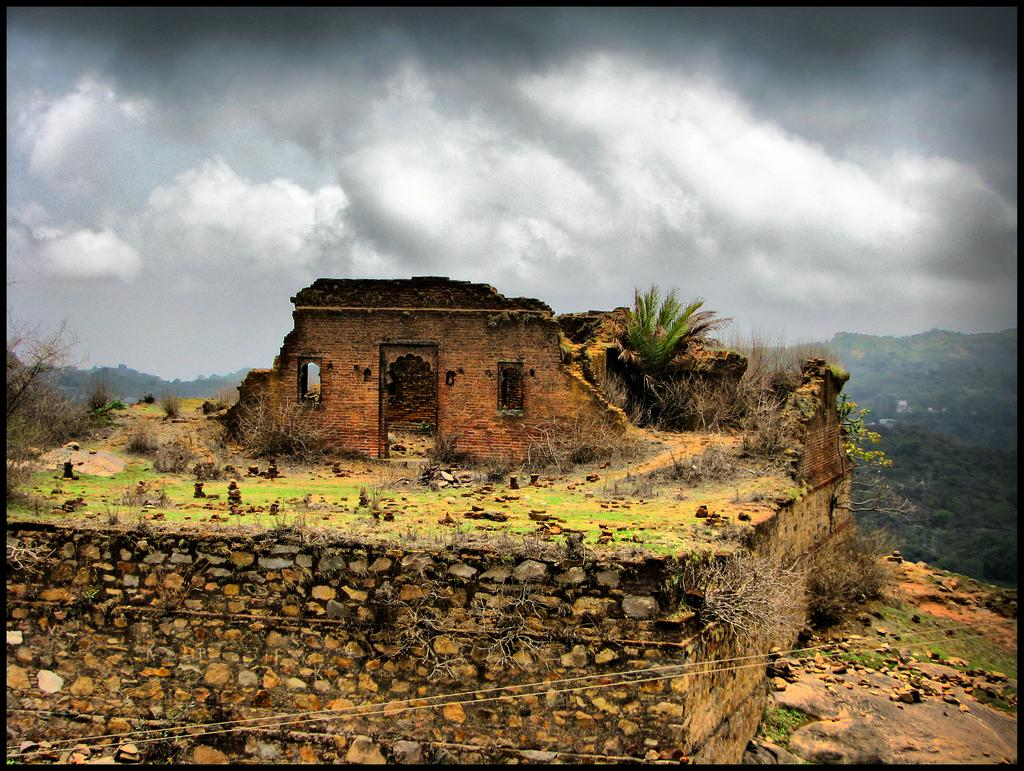What is the main subject of the image? The main subject of the image is a collapsed building. Are there any other objects or structures visible in the image? Yes, there are other objects beside the collapsed building. What can be seen in the background of the image? There are trees in the background of the image. How would you describe the weather based on the image? The sky is cloudy in the image, suggesting a potentially overcast or gloomy day. Where is the meeting taking place in the image? There is no meeting present in the image; it features a collapsed building and other objects. What type of vessel is being used to transport the trees in the image? There is no vessel present in the image, and the trees are not being transported; they are part of the background. 